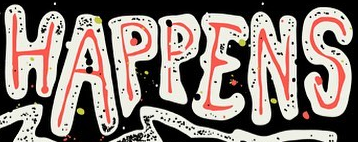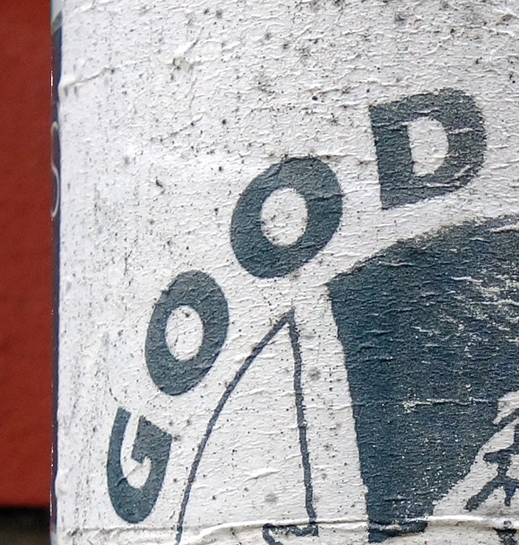What text appears in these images from left to right, separated by a semicolon? HAPPENS; GOOD 